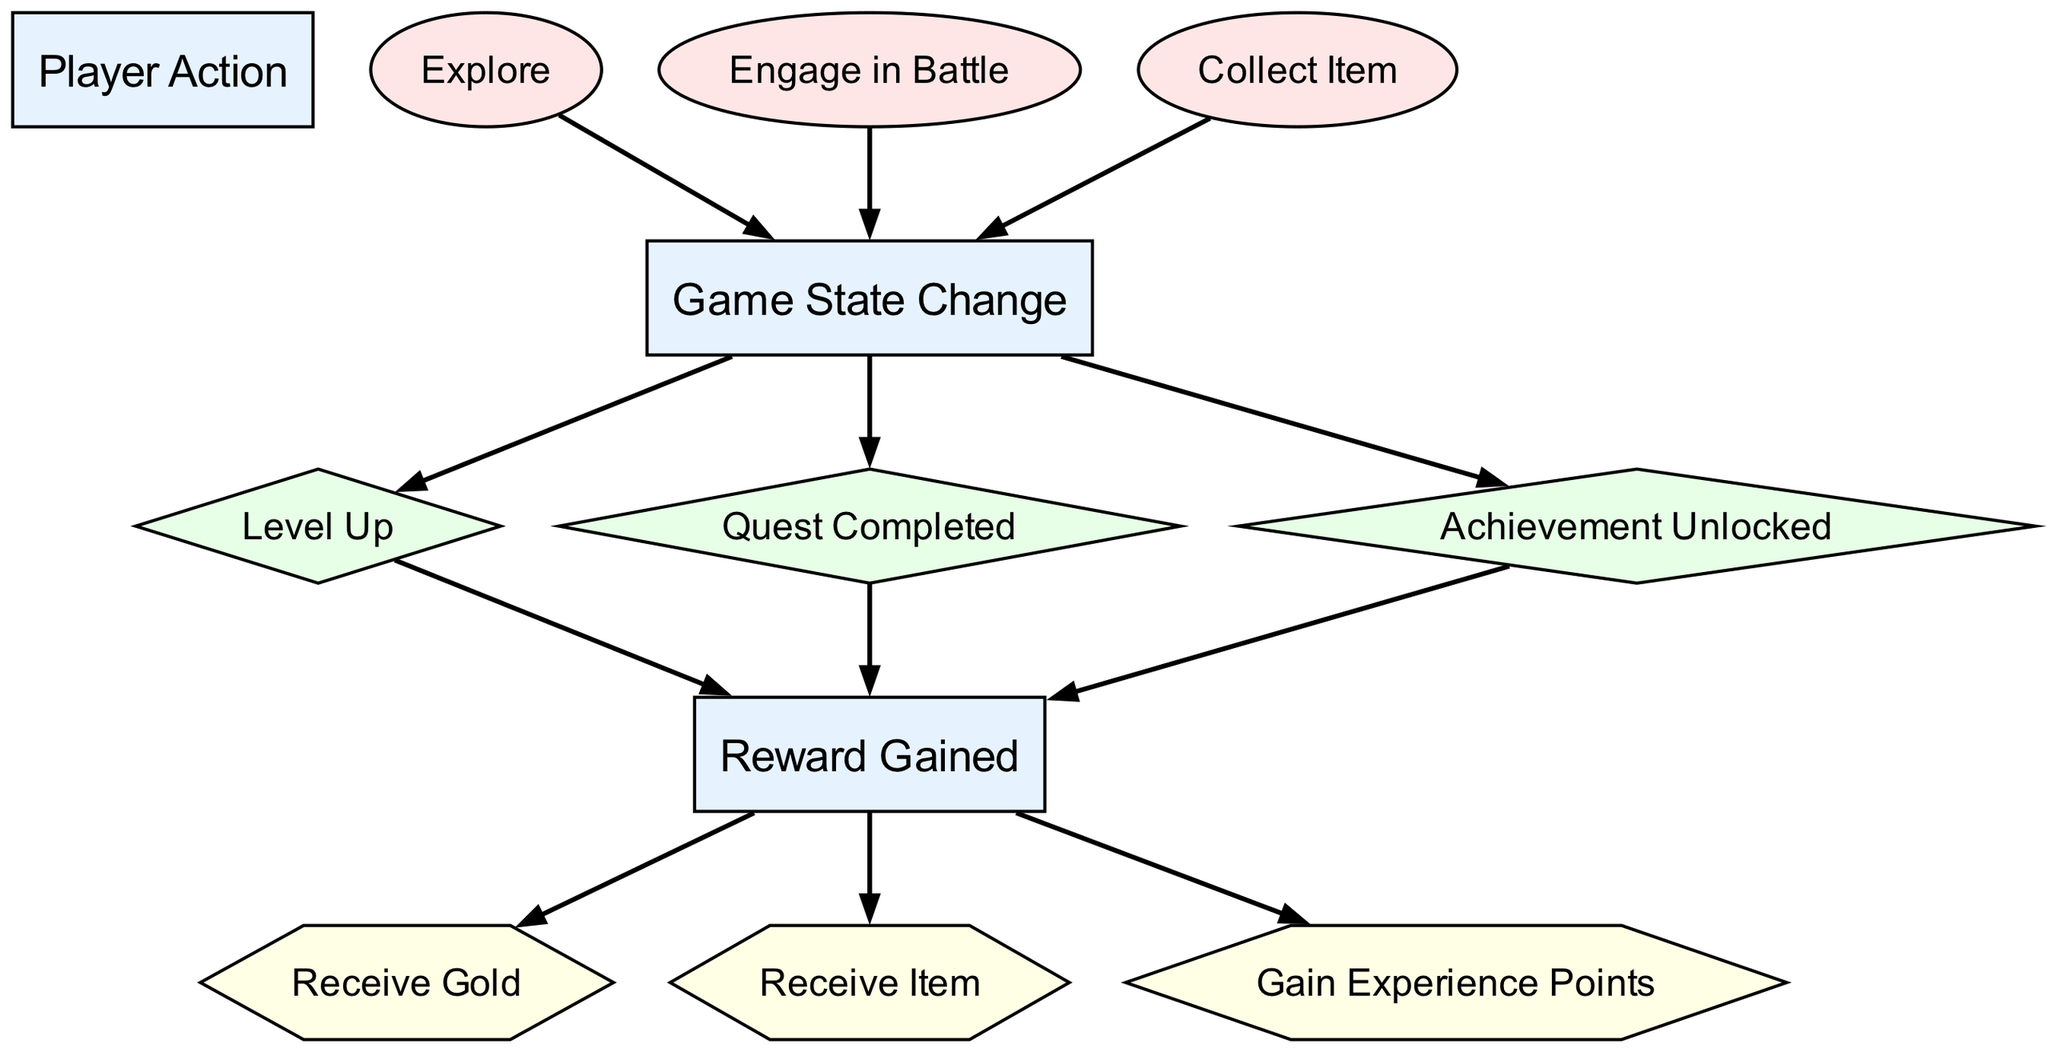What is the total number of nodes in the diagram? There are 12 nodes listed in the data under the "nodes" key. This includes player actions, game state changes, and rewards.
Answer: 12 Which node represents a player action involving confronting an enemy? The node labeled "Engage in Battle" specifically denotes the action of battling, which is a player action.
Answer: Engage in Battle What type is the node "Receive Item"? The node "Receive Item" is classified as a "Reward," as indicated by its type in the data.
Answer: Reward How many edges connect player actions to game state changes? There are three edges connecting player actions ("Explore," "Engage in Battle," and "Collect Item") to the "Game State Change" node, indicating player actions lead to changes in game states.
Answer: 3 What is the relationship between "Quest Completed" and "Reward Gained"? A directed edge connects "Quest Completed" to "Reward Gained," indicating that when a quest is completed, a reward is gained.
Answer: Reward Gained What happens after a player levels up? Following a player leveling up, the node "Reward" is reached, which signifies that leveling up results in gaining rewards.
Answer: Reward Which action leads to a game state change besides exploring? Both "Engage in Battle" and "Collect Item" are actions that lead to a "Game State Change," making them alternatives to exploring.
Answer: Engage in Battle, Collect Item What specific rewards can a player receive? The player can receive three specific types of rewards: "Gold," "Item," and "Experience Points," which are connected as outputs of the "Reward" node.
Answer: Gold, Item, Experience Points What connects "Achievement Unlocked" to the rewards system? The "Achievement Unlocked" node has a directed edge leading to the "Reward" node, indicating that unlocking an achievement grants rewards.
Answer: Reward 